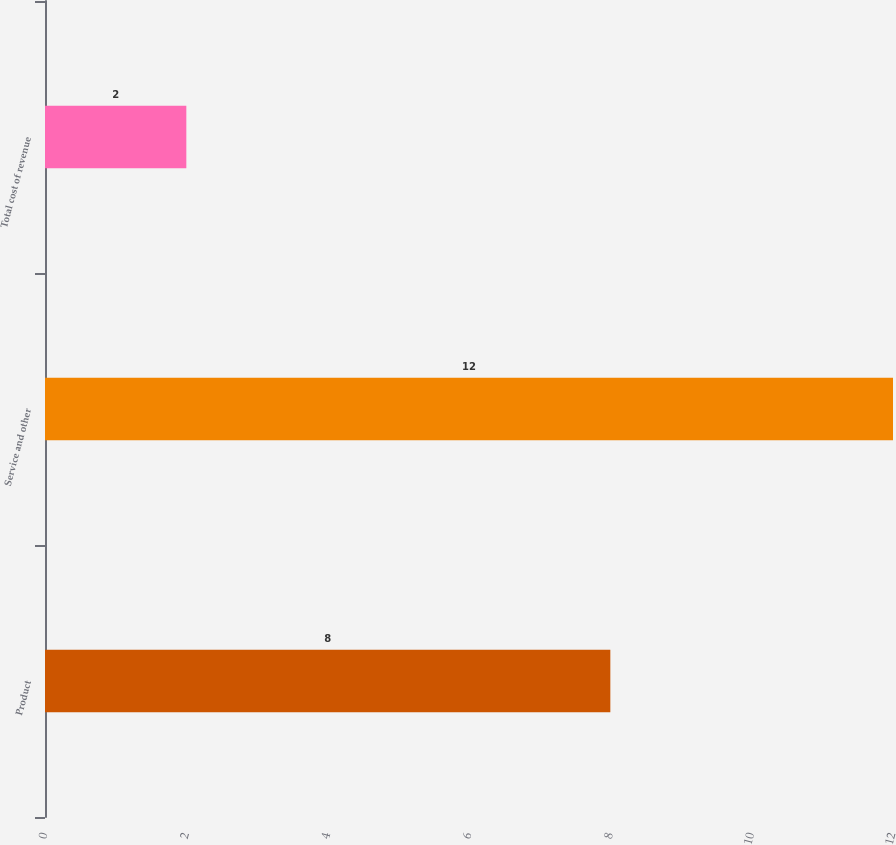Convert chart. <chart><loc_0><loc_0><loc_500><loc_500><bar_chart><fcel>Product<fcel>Service and other<fcel>Total cost of revenue<nl><fcel>8<fcel>12<fcel>2<nl></chart> 